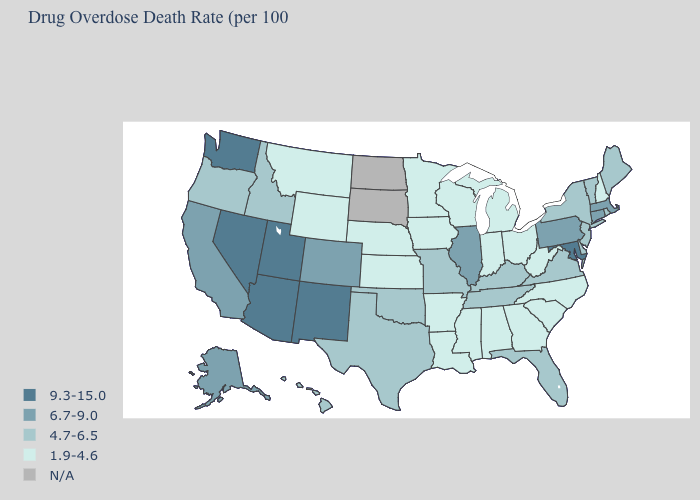Which states have the lowest value in the South?
Keep it brief. Alabama, Arkansas, Georgia, Louisiana, Mississippi, North Carolina, South Carolina, West Virginia. Name the states that have a value in the range 1.9-4.6?
Short answer required. Alabama, Arkansas, Georgia, Indiana, Iowa, Kansas, Louisiana, Michigan, Minnesota, Mississippi, Montana, Nebraska, New Hampshire, North Carolina, Ohio, South Carolina, West Virginia, Wisconsin, Wyoming. Is the legend a continuous bar?
Short answer required. No. Which states have the lowest value in the USA?
Short answer required. Alabama, Arkansas, Georgia, Indiana, Iowa, Kansas, Louisiana, Michigan, Minnesota, Mississippi, Montana, Nebraska, New Hampshire, North Carolina, Ohio, South Carolina, West Virginia, Wisconsin, Wyoming. Is the legend a continuous bar?
Be succinct. No. What is the lowest value in the USA?
Be succinct. 1.9-4.6. What is the value of Pennsylvania?
Write a very short answer. 6.7-9.0. Name the states that have a value in the range 6.7-9.0?
Be succinct. Alaska, California, Colorado, Connecticut, Illinois, Massachusetts, Pennsylvania. Name the states that have a value in the range N/A?
Concise answer only. North Dakota, South Dakota. What is the lowest value in the USA?
Keep it brief. 1.9-4.6. Does Nebraska have the lowest value in the USA?
Answer briefly. Yes. Is the legend a continuous bar?
Short answer required. No. Does the map have missing data?
Give a very brief answer. Yes. What is the lowest value in the West?
Be succinct. 1.9-4.6. What is the value of Washington?
Give a very brief answer. 9.3-15.0. 